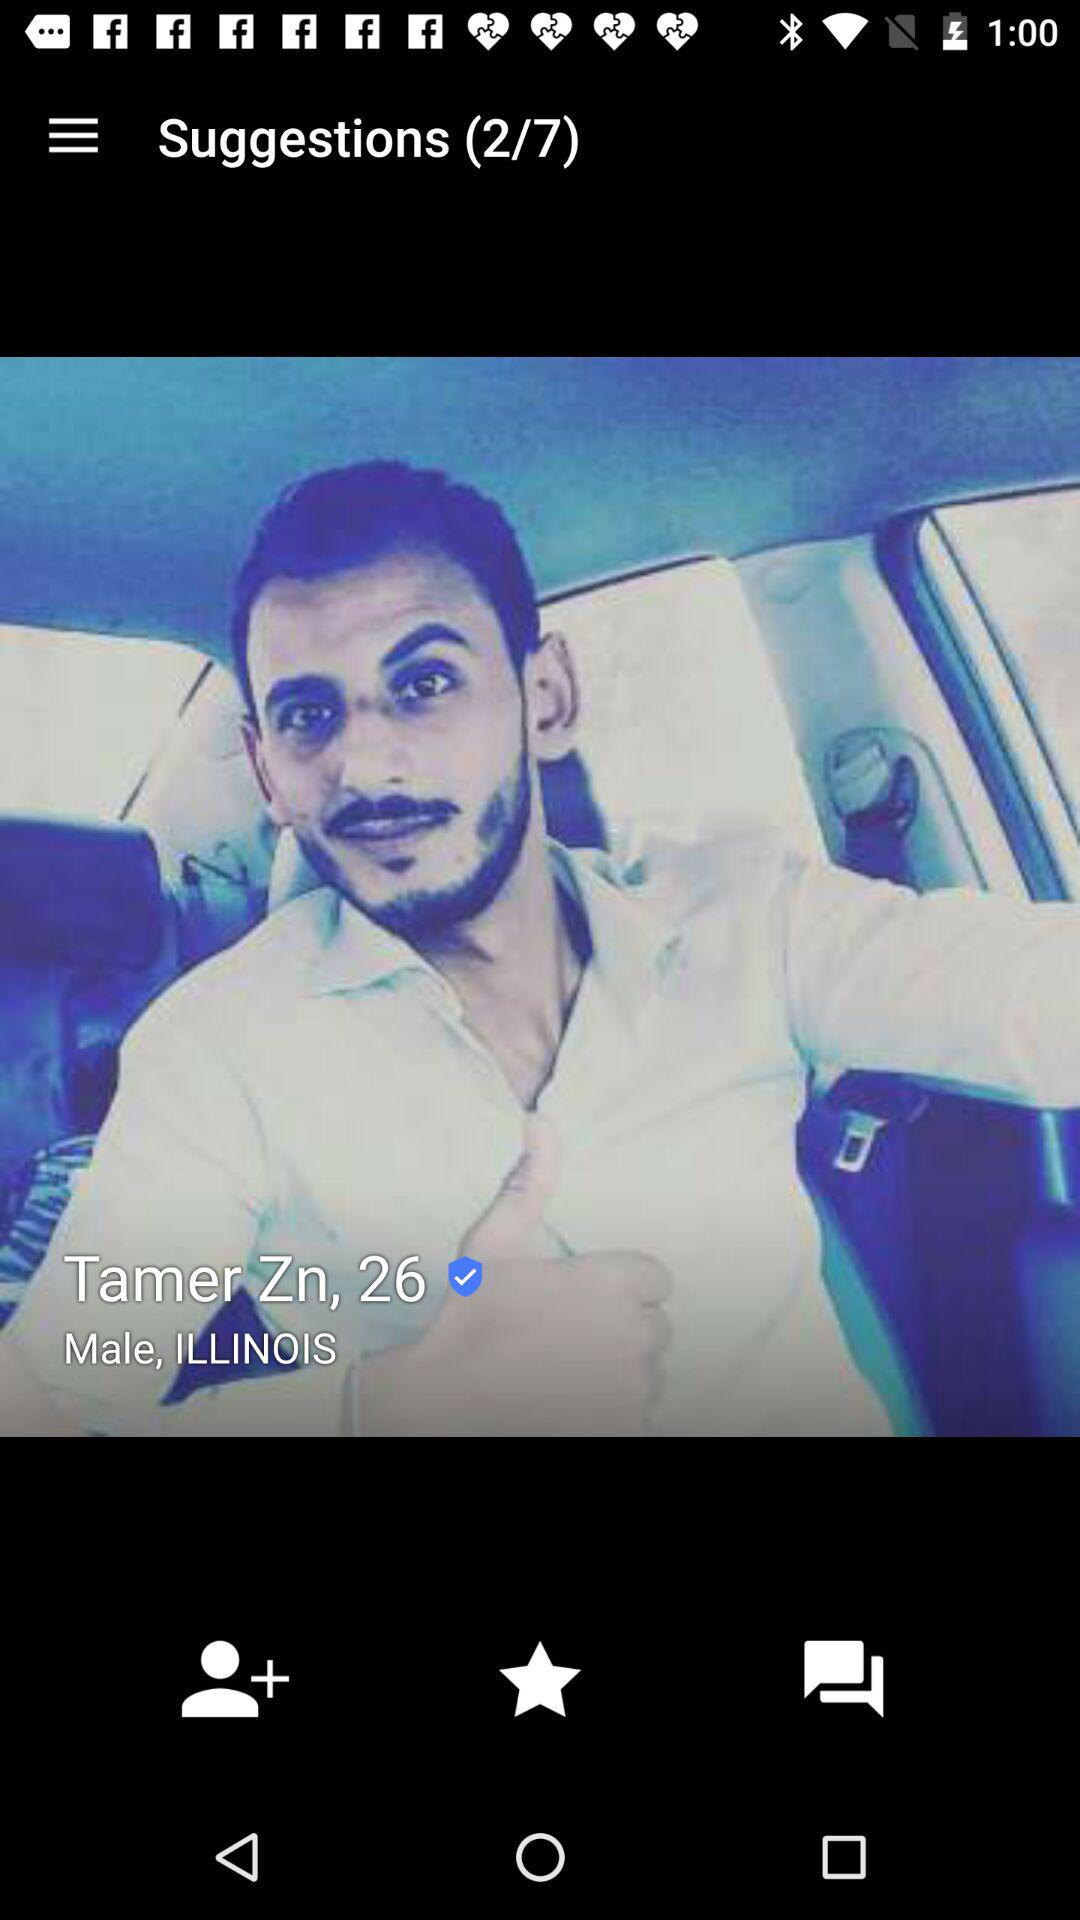What is the age? The age is 26 years old. 